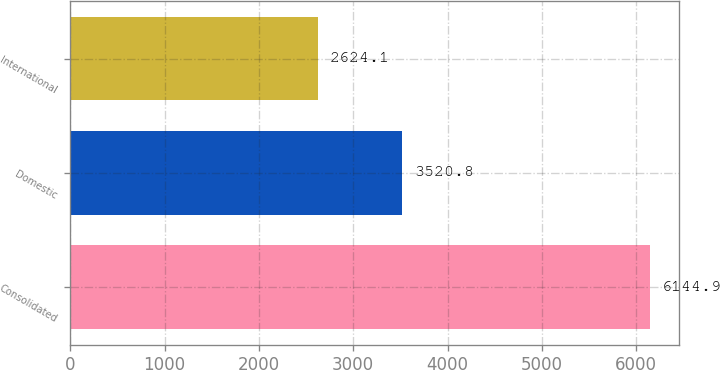<chart> <loc_0><loc_0><loc_500><loc_500><bar_chart><fcel>Consolidated<fcel>Domestic<fcel>International<nl><fcel>6144.9<fcel>3520.8<fcel>2624.1<nl></chart> 